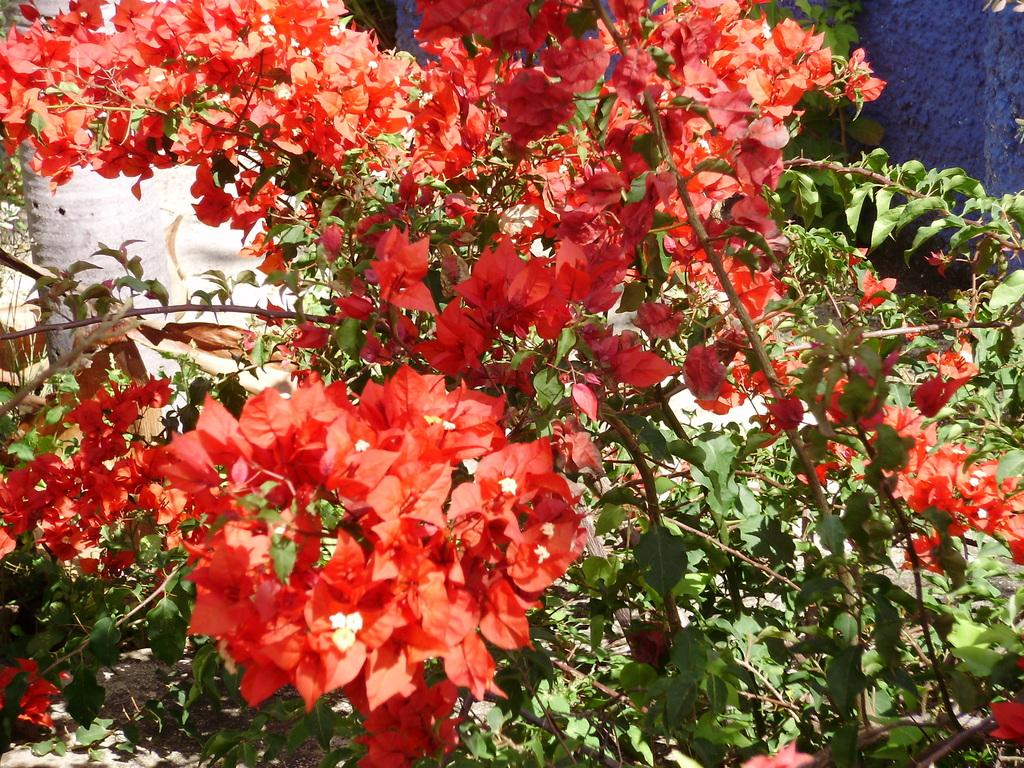What type of vegetation is present in the image? There are trees with flowers in the image. What can be seen in the background of the image? There is a wall in the background of the image. What type of sign is hanging on the trees in the image? There is no sign present in the image; it features trees with flowers and a wall in the background. What musical instrument can be heard playing in the background of the image? There is no musical instrument present in the image, as it only features trees with flowers and a wall in the background. 